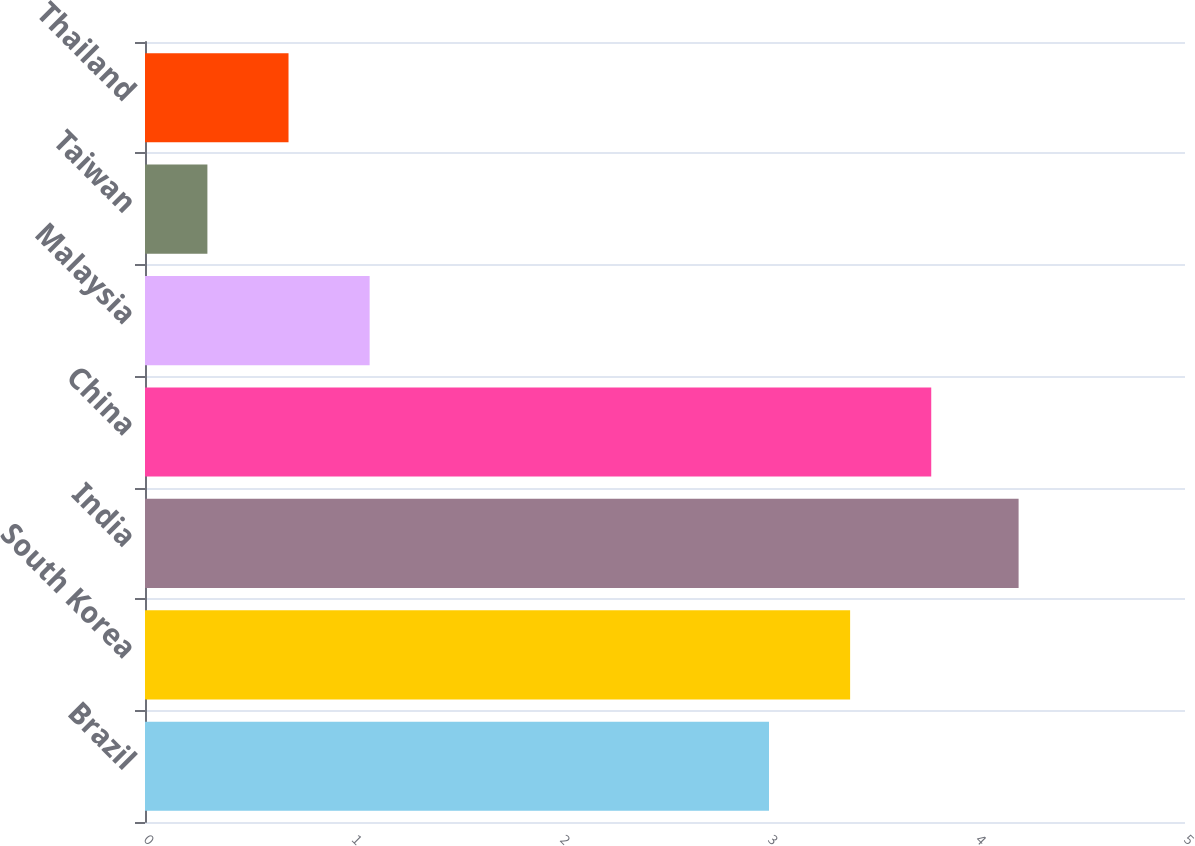<chart> <loc_0><loc_0><loc_500><loc_500><bar_chart><fcel>Brazil<fcel>South Korea<fcel>India<fcel>China<fcel>Malaysia<fcel>Taiwan<fcel>Thailand<nl><fcel>3<fcel>3.39<fcel>4.2<fcel>3.78<fcel>1.08<fcel>0.3<fcel>0.69<nl></chart> 